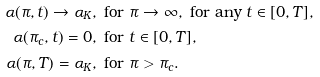<formula> <loc_0><loc_0><loc_500><loc_500>\alpha ( \pi , t ) \rightarrow \alpha _ { K } , & \, \text { for } \pi \rightarrow \infty , \text { for any } t \in [ 0 , T ] , \\ \alpha ( \pi _ { c } , t ) = 0 , & \, \text { for } t \in [ 0 , T ] , \\ \ \alpha ( \pi , T ) = \alpha _ { K } , & \, \text { for } \pi > \pi _ { c } .</formula> 